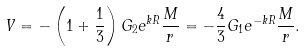<formula> <loc_0><loc_0><loc_500><loc_500>V = - \left ( 1 + \frac { 1 } { 3 } \right ) G _ { 2 } e ^ { k R } \frac { M } { r } = - \frac { 4 } { 3 } G _ { 1 } e ^ { - k R } \frac { M } { r } .</formula> 